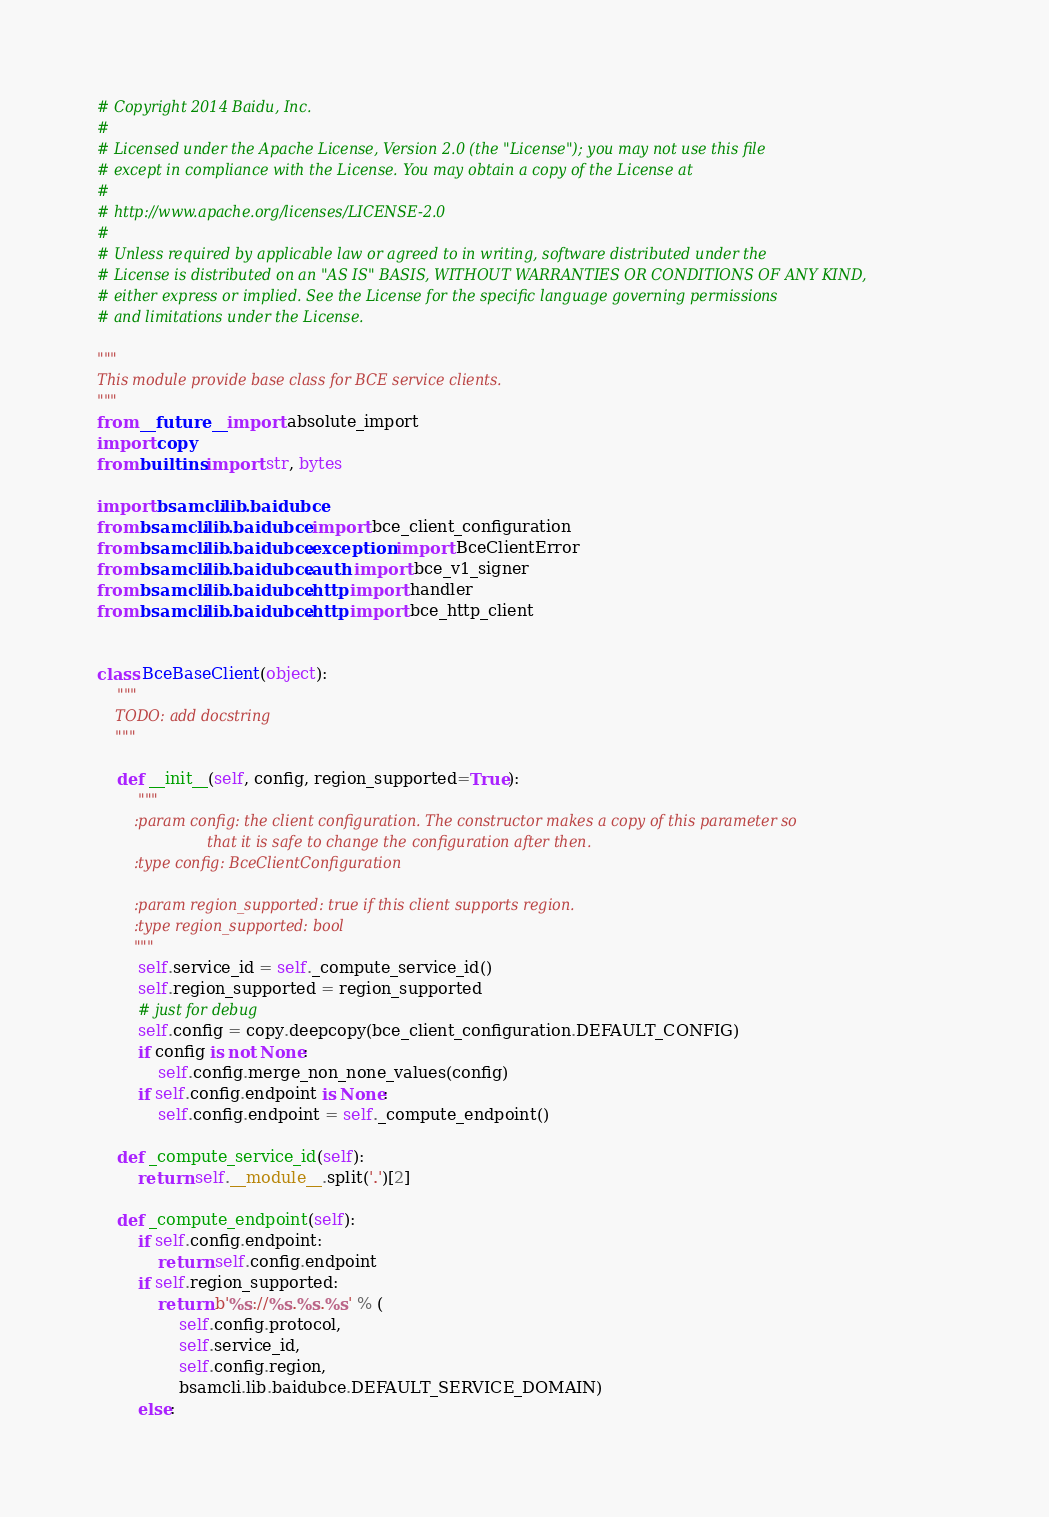<code> <loc_0><loc_0><loc_500><loc_500><_Python_># Copyright 2014 Baidu, Inc.
#
# Licensed under the Apache License, Version 2.0 (the "License"); you may not use this file
# except in compliance with the License. You may obtain a copy of the License at
#
# http://www.apache.org/licenses/LICENSE-2.0
#
# Unless required by applicable law or agreed to in writing, software distributed under the
# License is distributed on an "AS IS" BASIS, WITHOUT WARRANTIES OR CONDITIONS OF ANY KIND,
# either express or implied. See the License for the specific language governing permissions
# and limitations under the License.

"""
This module provide base class for BCE service clients.
"""
from __future__ import absolute_import
import copy
from builtins import str, bytes

import bsamcli.lib.baidubce
from bsamcli.lib.baidubce import bce_client_configuration
from bsamcli.lib.baidubce.exception import BceClientError
from bsamcli.lib.baidubce.auth import bce_v1_signer
from bsamcli.lib.baidubce.http import handler
from bsamcli.lib.baidubce.http import bce_http_client


class BceBaseClient(object):
    """
    TODO: add docstring
    """

    def __init__(self, config, region_supported=True):
        """
        :param config: the client configuration. The constructor makes a copy of this parameter so
                        that it is safe to change the configuration after then.
        :type config: BceClientConfiguration

        :param region_supported: true if this client supports region.
        :type region_supported: bool
        """
        self.service_id = self._compute_service_id()
        self.region_supported = region_supported
        # just for debug
        self.config = copy.deepcopy(bce_client_configuration.DEFAULT_CONFIG)
        if config is not None:
            self.config.merge_non_none_values(config)
        if self.config.endpoint is None:
            self.config.endpoint = self._compute_endpoint()

    def _compute_service_id(self):
        return self.__module__.split('.')[2]

    def _compute_endpoint(self):
        if self.config.endpoint:
            return self.config.endpoint
        if self.region_supported:
            return b'%s://%s.%s.%s' % (
                self.config.protocol,
                self.service_id,
                self.config.region,
                bsamcli.lib.baidubce.DEFAULT_SERVICE_DOMAIN)
        else:</code> 